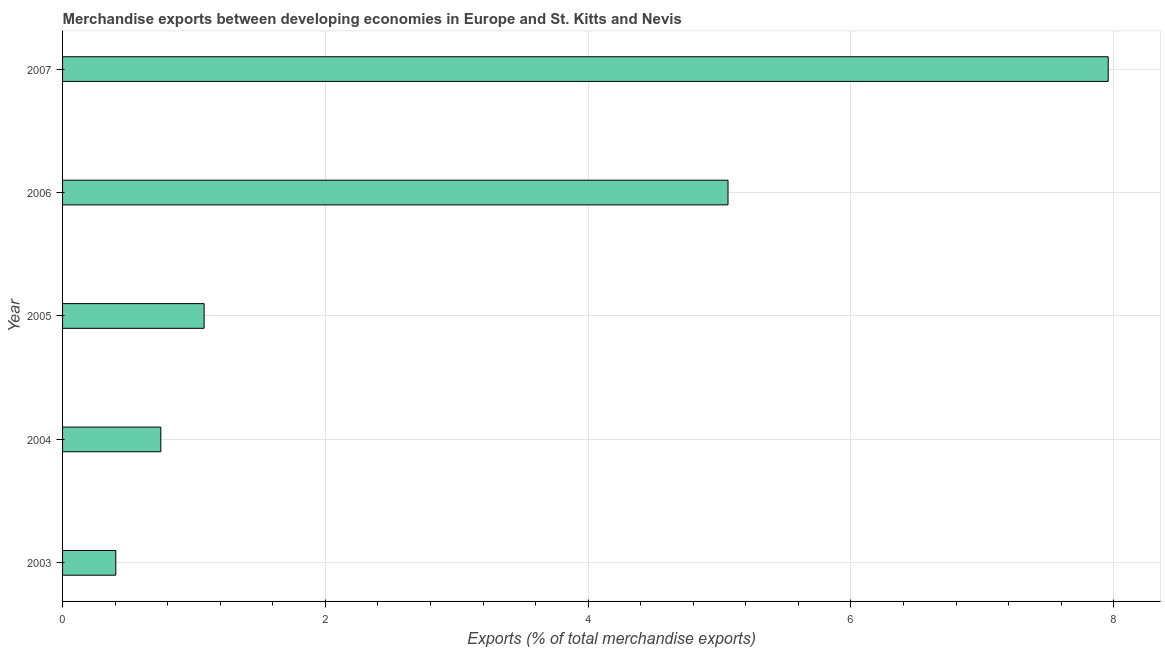Does the graph contain any zero values?
Offer a terse response. No. What is the title of the graph?
Your answer should be very brief. Merchandise exports between developing economies in Europe and St. Kitts and Nevis. What is the label or title of the X-axis?
Keep it short and to the point. Exports (% of total merchandise exports). What is the merchandise exports in 2004?
Your answer should be very brief. 0.75. Across all years, what is the maximum merchandise exports?
Offer a terse response. 7.96. Across all years, what is the minimum merchandise exports?
Provide a short and direct response. 0.41. In which year was the merchandise exports minimum?
Make the answer very short. 2003. What is the sum of the merchandise exports?
Your response must be concise. 15.25. What is the difference between the merchandise exports in 2004 and 2005?
Provide a short and direct response. -0.33. What is the average merchandise exports per year?
Make the answer very short. 3.05. What is the median merchandise exports?
Make the answer very short. 1.08. Do a majority of the years between 2006 and 2004 (inclusive) have merchandise exports greater than 3.2 %?
Provide a short and direct response. Yes. What is the ratio of the merchandise exports in 2004 to that in 2005?
Make the answer very short. 0.69. Is the merchandise exports in 2004 less than that in 2005?
Offer a very short reply. Yes. What is the difference between the highest and the second highest merchandise exports?
Offer a very short reply. 2.89. Is the sum of the merchandise exports in 2003 and 2006 greater than the maximum merchandise exports across all years?
Give a very brief answer. No. What is the difference between the highest and the lowest merchandise exports?
Offer a very short reply. 7.55. In how many years, is the merchandise exports greater than the average merchandise exports taken over all years?
Make the answer very short. 2. How many bars are there?
Offer a very short reply. 5. Are all the bars in the graph horizontal?
Your answer should be very brief. Yes. Are the values on the major ticks of X-axis written in scientific E-notation?
Offer a terse response. No. What is the Exports (% of total merchandise exports) of 2003?
Offer a very short reply. 0.41. What is the Exports (% of total merchandise exports) of 2004?
Ensure brevity in your answer.  0.75. What is the Exports (% of total merchandise exports) in 2005?
Offer a terse response. 1.08. What is the Exports (% of total merchandise exports) of 2006?
Keep it short and to the point. 5.06. What is the Exports (% of total merchandise exports) in 2007?
Offer a very short reply. 7.96. What is the difference between the Exports (% of total merchandise exports) in 2003 and 2004?
Your answer should be very brief. -0.34. What is the difference between the Exports (% of total merchandise exports) in 2003 and 2005?
Provide a short and direct response. -0.67. What is the difference between the Exports (% of total merchandise exports) in 2003 and 2006?
Your answer should be compact. -4.66. What is the difference between the Exports (% of total merchandise exports) in 2003 and 2007?
Give a very brief answer. -7.55. What is the difference between the Exports (% of total merchandise exports) in 2004 and 2005?
Provide a succinct answer. -0.33. What is the difference between the Exports (% of total merchandise exports) in 2004 and 2006?
Offer a terse response. -4.32. What is the difference between the Exports (% of total merchandise exports) in 2004 and 2007?
Your response must be concise. -7.21. What is the difference between the Exports (% of total merchandise exports) in 2005 and 2006?
Ensure brevity in your answer.  -3.99. What is the difference between the Exports (% of total merchandise exports) in 2005 and 2007?
Give a very brief answer. -6.88. What is the difference between the Exports (% of total merchandise exports) in 2006 and 2007?
Provide a succinct answer. -2.89. What is the ratio of the Exports (% of total merchandise exports) in 2003 to that in 2004?
Ensure brevity in your answer.  0.54. What is the ratio of the Exports (% of total merchandise exports) in 2003 to that in 2005?
Provide a short and direct response. 0.38. What is the ratio of the Exports (% of total merchandise exports) in 2003 to that in 2007?
Make the answer very short. 0.05. What is the ratio of the Exports (% of total merchandise exports) in 2004 to that in 2005?
Keep it short and to the point. 0.69. What is the ratio of the Exports (% of total merchandise exports) in 2004 to that in 2006?
Give a very brief answer. 0.15. What is the ratio of the Exports (% of total merchandise exports) in 2004 to that in 2007?
Provide a succinct answer. 0.09. What is the ratio of the Exports (% of total merchandise exports) in 2005 to that in 2006?
Make the answer very short. 0.21. What is the ratio of the Exports (% of total merchandise exports) in 2005 to that in 2007?
Provide a succinct answer. 0.14. What is the ratio of the Exports (% of total merchandise exports) in 2006 to that in 2007?
Your answer should be very brief. 0.64. 